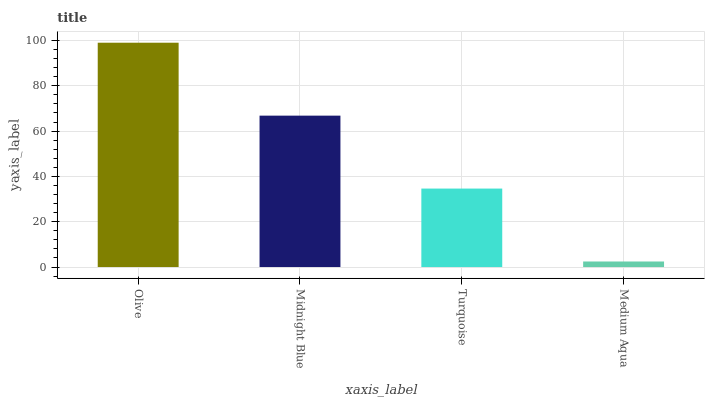Is Medium Aqua the minimum?
Answer yes or no. Yes. Is Olive the maximum?
Answer yes or no. Yes. Is Midnight Blue the minimum?
Answer yes or no. No. Is Midnight Blue the maximum?
Answer yes or no. No. Is Olive greater than Midnight Blue?
Answer yes or no. Yes. Is Midnight Blue less than Olive?
Answer yes or no. Yes. Is Midnight Blue greater than Olive?
Answer yes or no. No. Is Olive less than Midnight Blue?
Answer yes or no. No. Is Midnight Blue the high median?
Answer yes or no. Yes. Is Turquoise the low median?
Answer yes or no. Yes. Is Medium Aqua the high median?
Answer yes or no. No. Is Midnight Blue the low median?
Answer yes or no. No. 